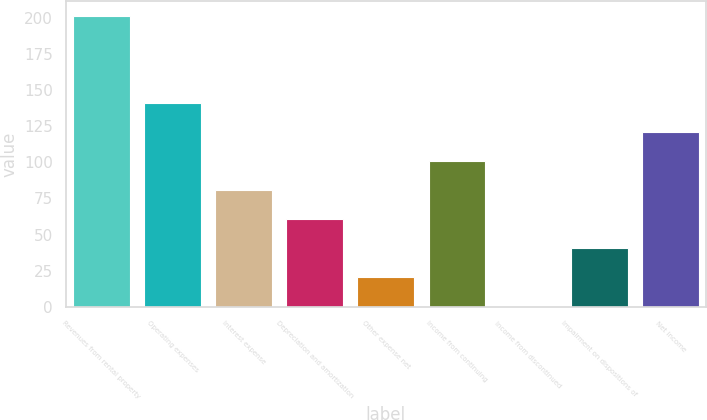<chart> <loc_0><loc_0><loc_500><loc_500><bar_chart><fcel>Revenues from rental property<fcel>Operating expenses<fcel>Interest expense<fcel>Depreciation and amortization<fcel>Other expense net<fcel>Income from continuing<fcel>Income from discontinued<fcel>Impairment on dispositions of<fcel>Net income<nl><fcel>201.6<fcel>141.18<fcel>80.76<fcel>60.62<fcel>20.34<fcel>100.9<fcel>0.2<fcel>40.48<fcel>121.04<nl></chart> 